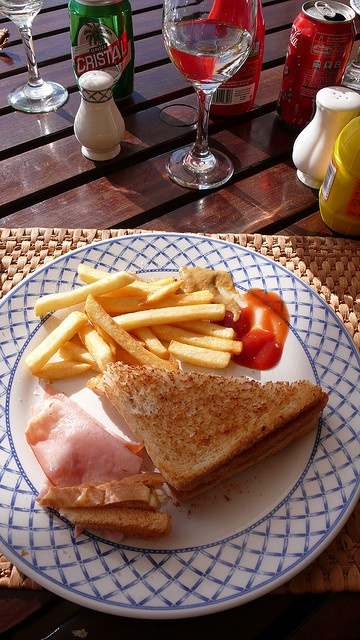Describe the objects in this image and their specific colors. I can see dining table in black, maroon, gray, lightgray, and darkgray tones, sandwich in darkgray, brown, maroon, and gray tones, sandwich in darkgray, brown, lightgray, and maroon tones, wine glass in darkgray, gray, maroon, and black tones, and wine glass in gray, lightgray, and darkgray tones in this image. 